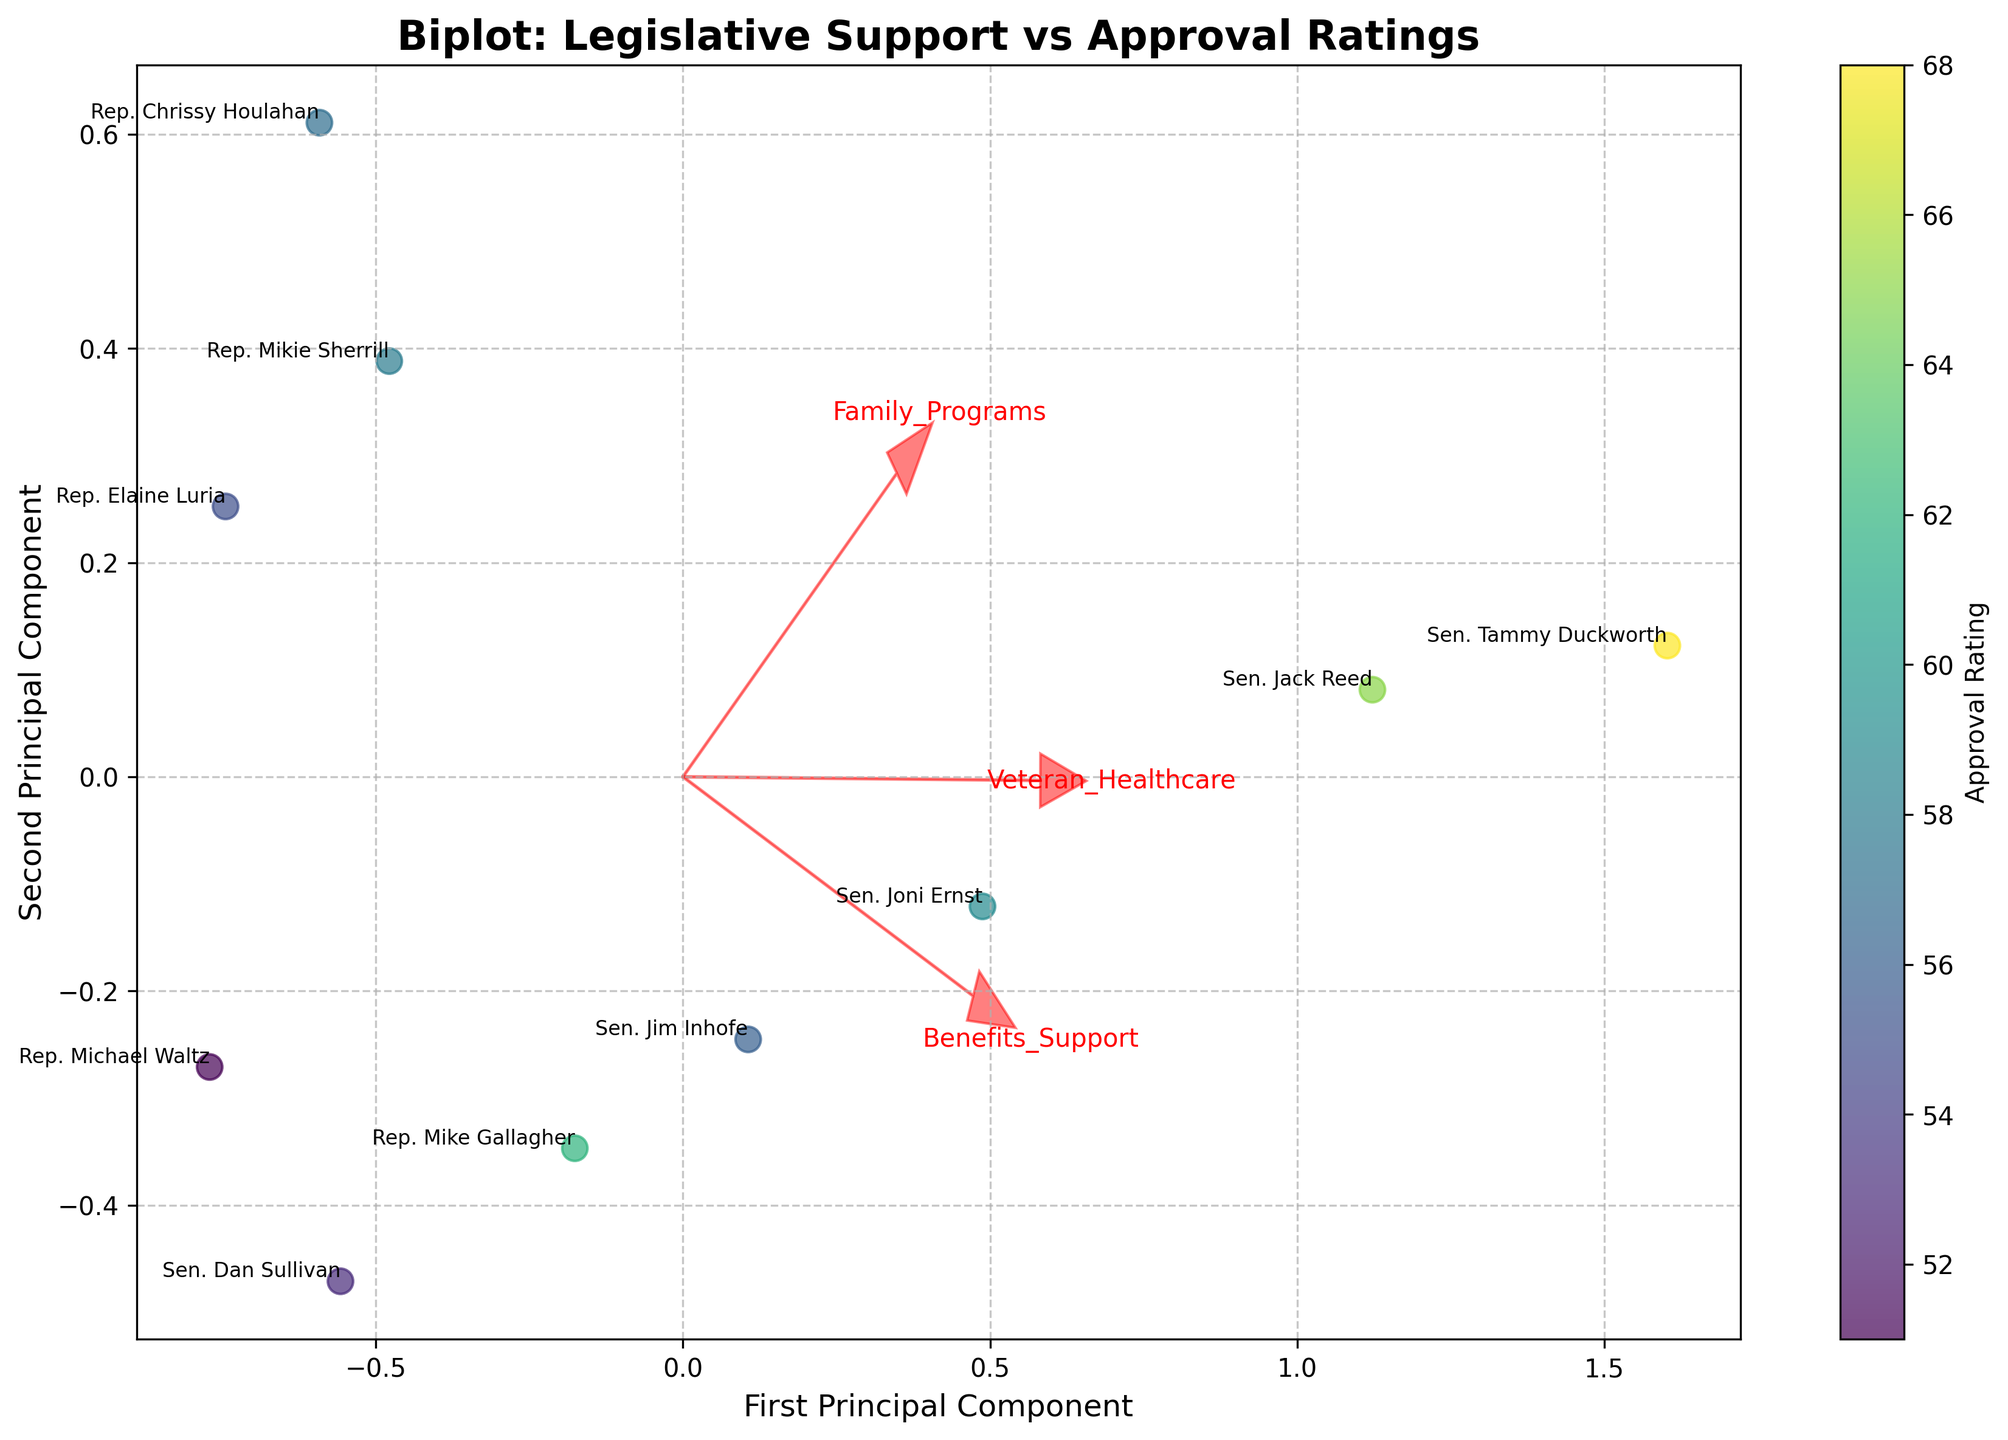How many data points are represented in the plot? By observing the figure, count the number of labeled data points or markers on the scatter plot. Each data point corresponds to a legislator.
Answer: 10 What does the x-axis represent? The label on the x-axis indicates what it measures. In a PCA biplot, the axis typically represents a principal component.
Answer: First Principal Component Which legislator has the highest approval rating and where can they be found on the plot? Identify which data point is associated with the highest Approval Rating by observing the color gradient or labeled approval ratings. Locate the corresponding legislator on the plot.
Answer: Sen. Tammy Duckworth What is the range of the approval ratings shown on the colorbar? Look at the colorbar next to the scatter plot. Identify the lowest and highest values indicated on the colorbar.
Answer: 51 to 68 Which features are indicated by the red arrows? Observe the labels attached to the red arrows on the plot. These correspond to the variables or features associated with the data.
Answer: Benefits_Support, Family_Programs, Veteran_Healthcare Is the second principal component (y-axis) positively or negatively correlated with Family Programs? Examine the direction of the red arrow for Family Programs relative to the y-axis. If the arrow points upwards, the correlation is positive; if it points downwards, it is negative.
Answer: Positively Which two features are most closely aligned in terms of their eigenvectors? Look for red arrows that point in similar directions. If two arrows are closely aligned, it indicates that the features they represent are closely related.
Answer: Benefits_Support and Veteran_Healthcare What is the average approval rating of legislators who have Support Scores above 8 in Benefits_Support? Identify the data points or legislators with a Benefits_Support score greater than 8. Sum their Approval Ratings and divide by the count of these legislators to find the average.
Answer: Average equals (68 + 65) / 2 = 66.5 Which legislator scores the highest on Family Programs and is there a clear correlation with their approval rating? Find the data point with the highest score in Family Programs by observing the positions and labels. Check the approval rating color and evaluate if there’s a general trend associated with this feature.
Answer: Sen. Tammy Duckworth, Yes Which component (x-axis or y-axis) captures more variability in the data? Determine which principal component captures more variance usually provided by the plot or implicit by labeling. In PCA, the first principal component generally captures more variance.
Answer: First Principal Component 